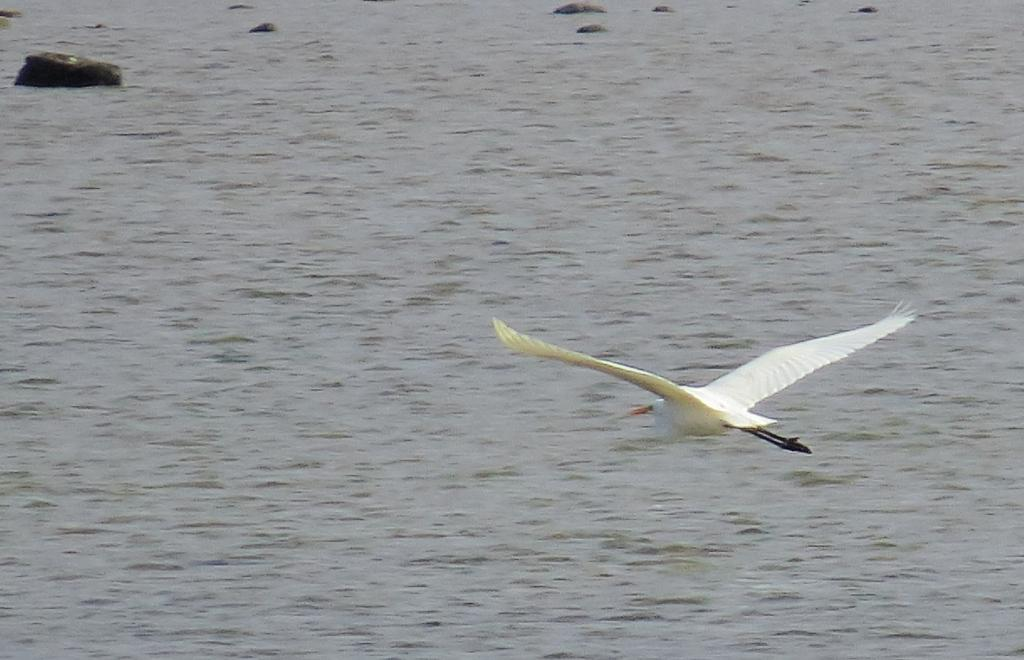What is the main subject of the image? There is a bird flying in the image. What can be seen in the background of the image? There is a water surface visible in the image. Are there any objects or features within the water? Yes, there are rocks in the water. Where is the faucet located in the image? There is no faucet present in the image. What color is the crayon being used by the bird in the image? There is no crayon or bird using a crayon in the image. 